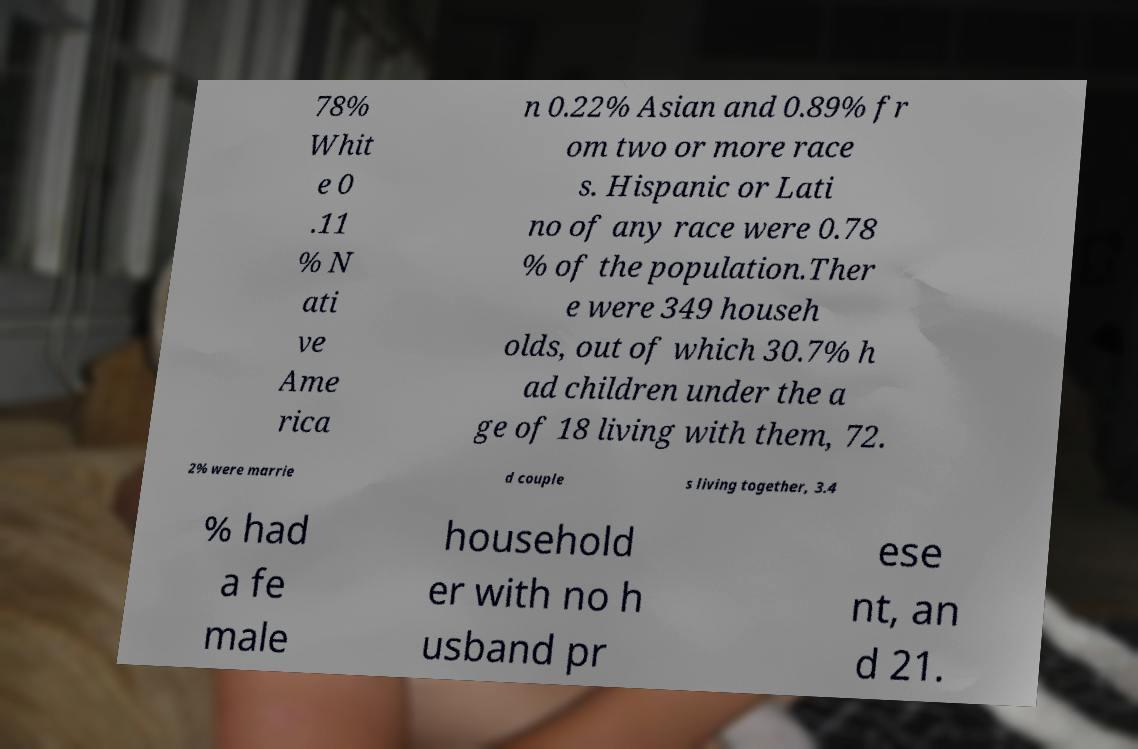For documentation purposes, I need the text within this image transcribed. Could you provide that? 78% Whit e 0 .11 % N ati ve Ame rica n 0.22% Asian and 0.89% fr om two or more race s. Hispanic or Lati no of any race were 0.78 % of the population.Ther e were 349 househ olds, out of which 30.7% h ad children under the a ge of 18 living with them, 72. 2% were marrie d couple s living together, 3.4 % had a fe male household er with no h usband pr ese nt, an d 21. 